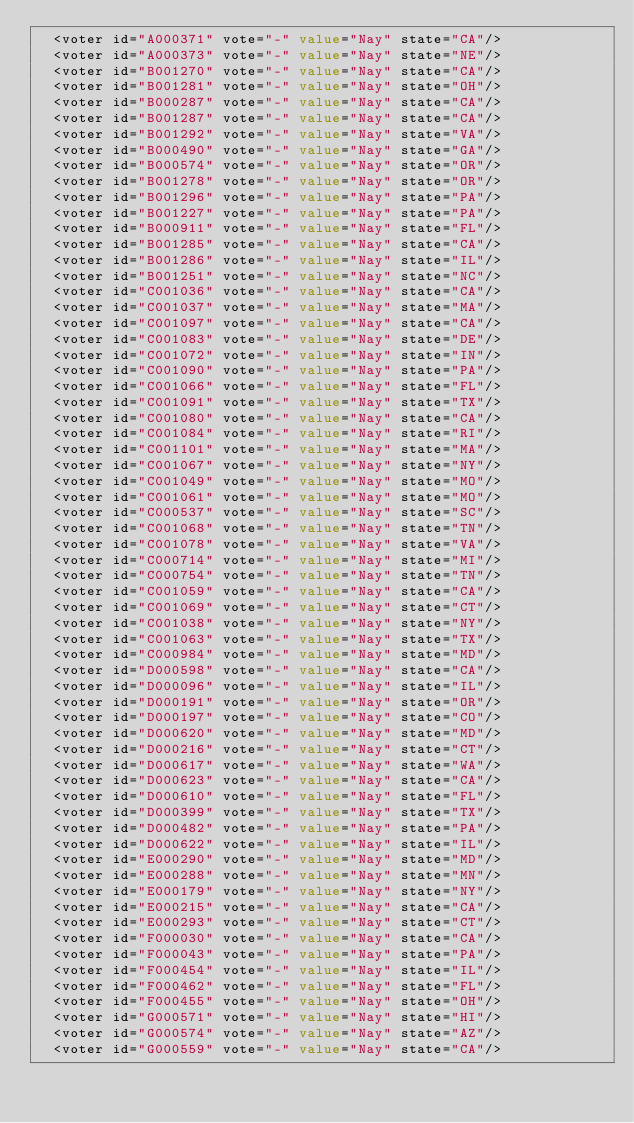<code> <loc_0><loc_0><loc_500><loc_500><_XML_>  <voter id="A000371" vote="-" value="Nay" state="CA"/>
  <voter id="A000373" vote="-" value="Nay" state="NE"/>
  <voter id="B001270" vote="-" value="Nay" state="CA"/>
  <voter id="B001281" vote="-" value="Nay" state="OH"/>
  <voter id="B000287" vote="-" value="Nay" state="CA"/>
  <voter id="B001287" vote="-" value="Nay" state="CA"/>
  <voter id="B001292" vote="-" value="Nay" state="VA"/>
  <voter id="B000490" vote="-" value="Nay" state="GA"/>
  <voter id="B000574" vote="-" value="Nay" state="OR"/>
  <voter id="B001278" vote="-" value="Nay" state="OR"/>
  <voter id="B001296" vote="-" value="Nay" state="PA"/>
  <voter id="B001227" vote="-" value="Nay" state="PA"/>
  <voter id="B000911" vote="-" value="Nay" state="FL"/>
  <voter id="B001285" vote="-" value="Nay" state="CA"/>
  <voter id="B001286" vote="-" value="Nay" state="IL"/>
  <voter id="B001251" vote="-" value="Nay" state="NC"/>
  <voter id="C001036" vote="-" value="Nay" state="CA"/>
  <voter id="C001037" vote="-" value="Nay" state="MA"/>
  <voter id="C001097" vote="-" value="Nay" state="CA"/>
  <voter id="C001083" vote="-" value="Nay" state="DE"/>
  <voter id="C001072" vote="-" value="Nay" state="IN"/>
  <voter id="C001090" vote="-" value="Nay" state="PA"/>
  <voter id="C001066" vote="-" value="Nay" state="FL"/>
  <voter id="C001091" vote="-" value="Nay" state="TX"/>
  <voter id="C001080" vote="-" value="Nay" state="CA"/>
  <voter id="C001084" vote="-" value="Nay" state="RI"/>
  <voter id="C001101" vote="-" value="Nay" state="MA"/>
  <voter id="C001067" vote="-" value="Nay" state="NY"/>
  <voter id="C001049" vote="-" value="Nay" state="MO"/>
  <voter id="C001061" vote="-" value="Nay" state="MO"/>
  <voter id="C000537" vote="-" value="Nay" state="SC"/>
  <voter id="C001068" vote="-" value="Nay" state="TN"/>
  <voter id="C001078" vote="-" value="Nay" state="VA"/>
  <voter id="C000714" vote="-" value="Nay" state="MI"/>
  <voter id="C000754" vote="-" value="Nay" state="TN"/>
  <voter id="C001059" vote="-" value="Nay" state="CA"/>
  <voter id="C001069" vote="-" value="Nay" state="CT"/>
  <voter id="C001038" vote="-" value="Nay" state="NY"/>
  <voter id="C001063" vote="-" value="Nay" state="TX"/>
  <voter id="C000984" vote="-" value="Nay" state="MD"/>
  <voter id="D000598" vote="-" value="Nay" state="CA"/>
  <voter id="D000096" vote="-" value="Nay" state="IL"/>
  <voter id="D000191" vote="-" value="Nay" state="OR"/>
  <voter id="D000197" vote="-" value="Nay" state="CO"/>
  <voter id="D000620" vote="-" value="Nay" state="MD"/>
  <voter id="D000216" vote="-" value="Nay" state="CT"/>
  <voter id="D000617" vote="-" value="Nay" state="WA"/>
  <voter id="D000623" vote="-" value="Nay" state="CA"/>
  <voter id="D000610" vote="-" value="Nay" state="FL"/>
  <voter id="D000399" vote="-" value="Nay" state="TX"/>
  <voter id="D000482" vote="-" value="Nay" state="PA"/>
  <voter id="D000622" vote="-" value="Nay" state="IL"/>
  <voter id="E000290" vote="-" value="Nay" state="MD"/>
  <voter id="E000288" vote="-" value="Nay" state="MN"/>
  <voter id="E000179" vote="-" value="Nay" state="NY"/>
  <voter id="E000215" vote="-" value="Nay" state="CA"/>
  <voter id="E000293" vote="-" value="Nay" state="CT"/>
  <voter id="F000030" vote="-" value="Nay" state="CA"/>
  <voter id="F000043" vote="-" value="Nay" state="PA"/>
  <voter id="F000454" vote="-" value="Nay" state="IL"/>
  <voter id="F000462" vote="-" value="Nay" state="FL"/>
  <voter id="F000455" vote="-" value="Nay" state="OH"/>
  <voter id="G000571" vote="-" value="Nay" state="HI"/>
  <voter id="G000574" vote="-" value="Nay" state="AZ"/>
  <voter id="G000559" vote="-" value="Nay" state="CA"/></code> 